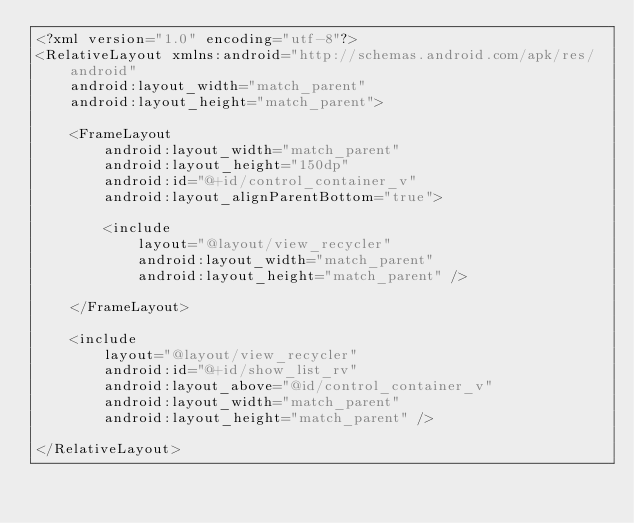Convert code to text. <code><loc_0><loc_0><loc_500><loc_500><_XML_><?xml version="1.0" encoding="utf-8"?>
<RelativeLayout xmlns:android="http://schemas.android.com/apk/res/android"
    android:layout_width="match_parent"
    android:layout_height="match_parent">

    <FrameLayout
        android:layout_width="match_parent"
        android:layout_height="150dp"
        android:id="@+id/control_container_v"
        android:layout_alignParentBottom="true">

        <include
            layout="@layout/view_recycler"
            android:layout_width="match_parent"
            android:layout_height="match_parent" />

    </FrameLayout>

    <include
        layout="@layout/view_recycler"
        android:id="@+id/show_list_rv"
        android:layout_above="@id/control_container_v"
        android:layout_width="match_parent"
        android:layout_height="match_parent" />

</RelativeLayout></code> 